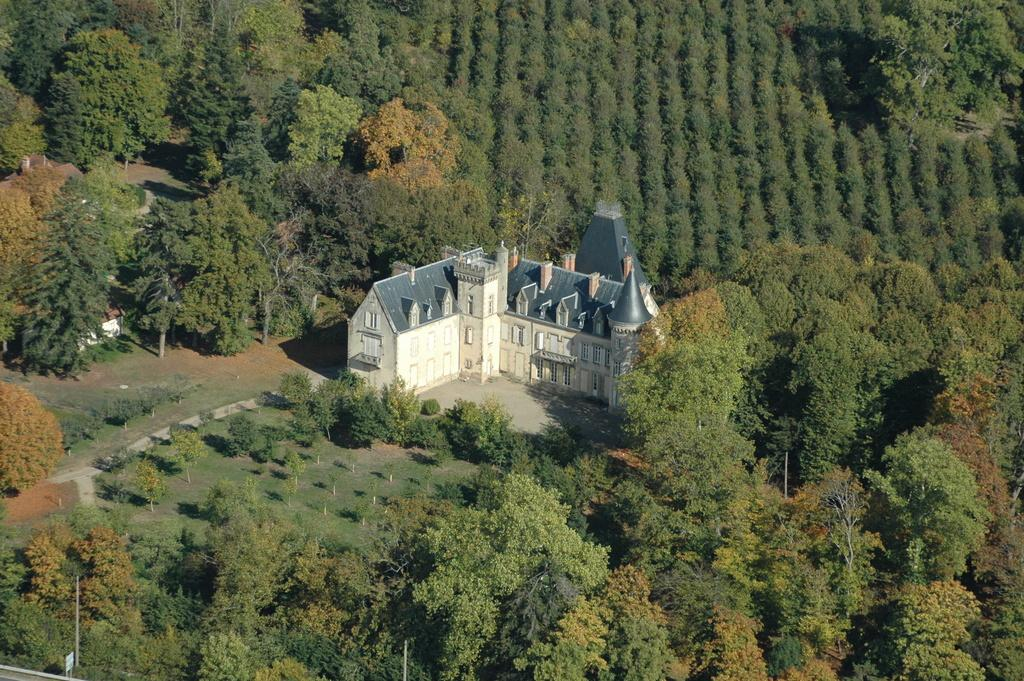What type of structures can be seen in the image? There are houses in the image. What type of vegetation is present in the image? There are trees in the image. How does the behavior of the trees change during an earthquake in the image? There is no earthquake present in the image, and therefore no change in the behavior of the trees can be observed. 